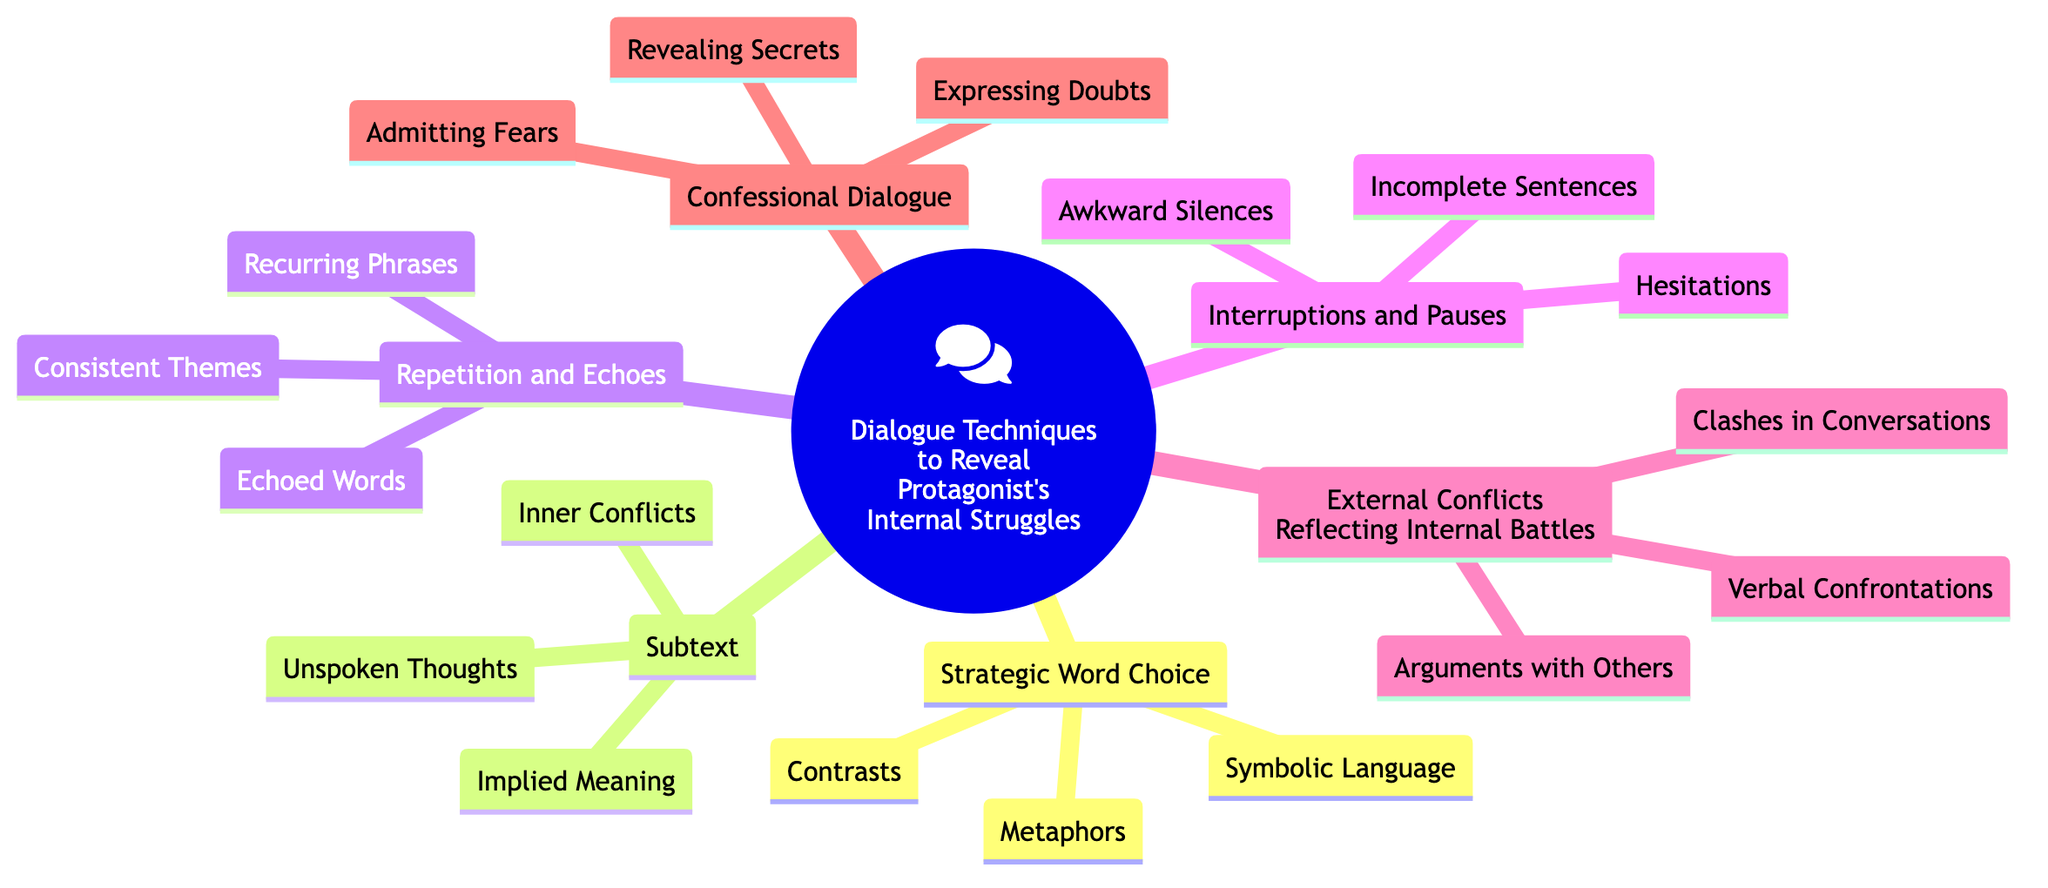What are the main branches of the mind map? The main branches include Strategic Word Choice, Subtext, Repetition and Echoes, Interruptions and Pauses, External Conflicts Reflecting Internal Battles, and Confessional Dialogue.
Answer: Strategic Word Choice, Subtext, Repetition and Echoes, Interruptions and Pauses, External Conflicts Reflecting Internal Battles, Confessional Dialogue How many sub-elements are listed under the "Subtext" branch? The branch "Subtext" has three sub-elements: Implied Meaning, Unspoken Thoughts, and Inner Conflicts. Counting these gives us a total of three.
Answer: 3 What dialogue technique relates to silent struggles? The "Interruptions and Pauses" section includes elements like Hesitations and Awkward Silences that can indicate silent struggles.
Answer: Interruptions and Pauses Which sub-element is associated with "Arguments with Others"? "Arguments with Others" is a specific sub-element listed under the branch "External Conflicts Reflecting Internal Battles." This clearly indicates its association.
Answer: Arguments with Others How many sub-elements are related to "Confessional Dialogue"? The "Confessional Dialogue" branch includes three sub-elements: Revealing Secrets, Admitting Fears, and Expressing Doubts. Therefore, the count of sub-elements here is three.
Answer: 3 What is the relationship between "Repetition and Echoes" and "Recurring Phrases"? "Recurring Phrases" is a sub-element under the branch "Repetition and Echoes," indicating that this phrase is part of the broader dialogue technique focusing on repetition.
Answer: Sub-element Which dialogue technique includes "Symbolic Language"? "Symbolic Language" is a sub-element found under the branch "Strategic Word Choice," thus linking it to that specific dialogue technique.
Answer: Strategic Word Choice What are the total number of sub-elements in the diagram? The total sub-elements can be calculated by adding all sub-elements across branches: 3 (Strategic Word Choice) + 3 (Subtext) + 3 (Repetition and Echoes) + 3 (Interruptions and Pauses) + 3 (External Conflicts Reflecting Internal Battles) + 3 (Confessional Dialogue), giving a total of 18.
Answer: 18 What common theme is indicated by "Consistent Themes"? "Consistent Themes" is a sub-element of "Repetition and Echoes," suggesting that recurring genres or motifs in dialogue can help express internal struggles consistently.
Answer: Repetition and Echoes 